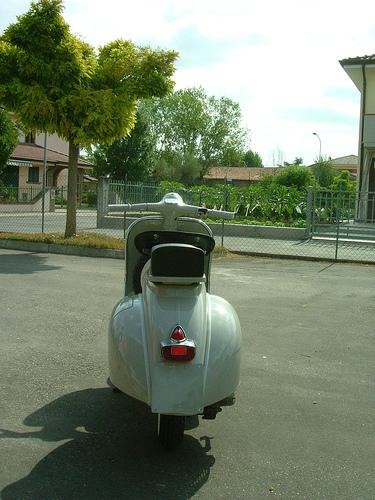How many unicorns are there in the image? There are no unicorns to be seen in this image. Unicorns are legendary creatures from folklore and are not found in the real world, and certainly, there are none in this photograph which features a charming vintage scooter. 